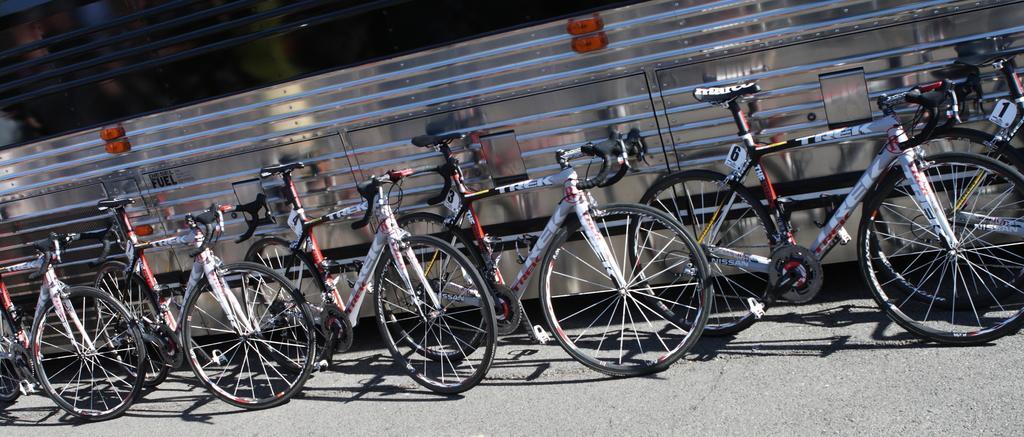Please provide a concise description of this image. In this picture we can see a few bicycles on the road. We can see the numbers on the white objects. There are the shadows of these bicycles on the road. We can see a few rods and some orange objects in the background. 